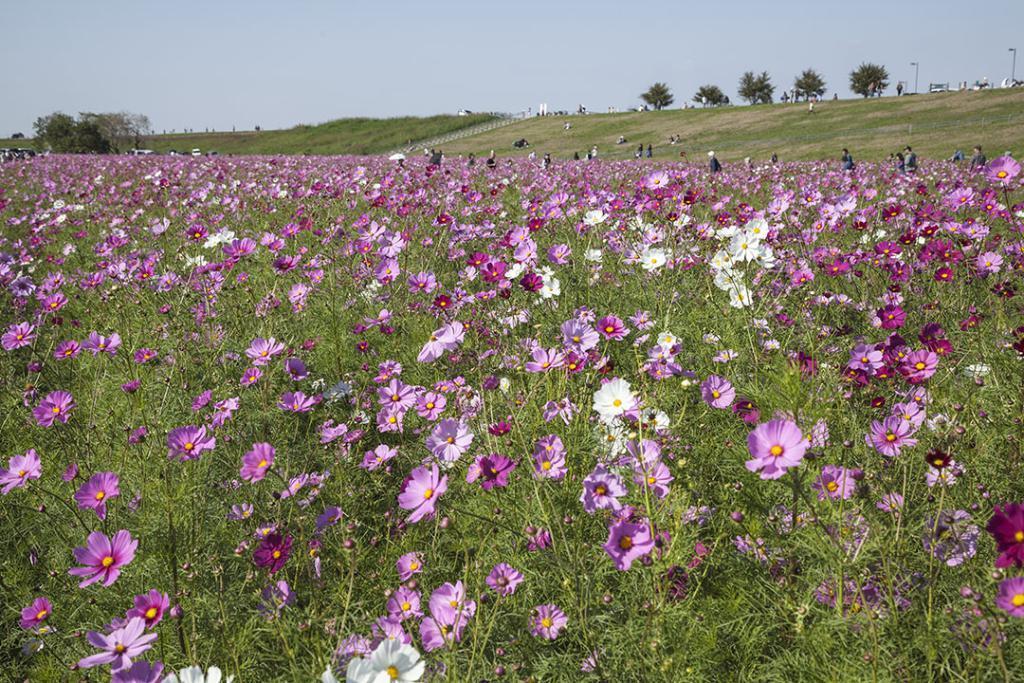In one or two sentences, can you explain what this image depicts? In this image, we can see some purple flowers, there is grass on the ground, we can see some trees on the right side top, there are some street lights, we can see the sky. 